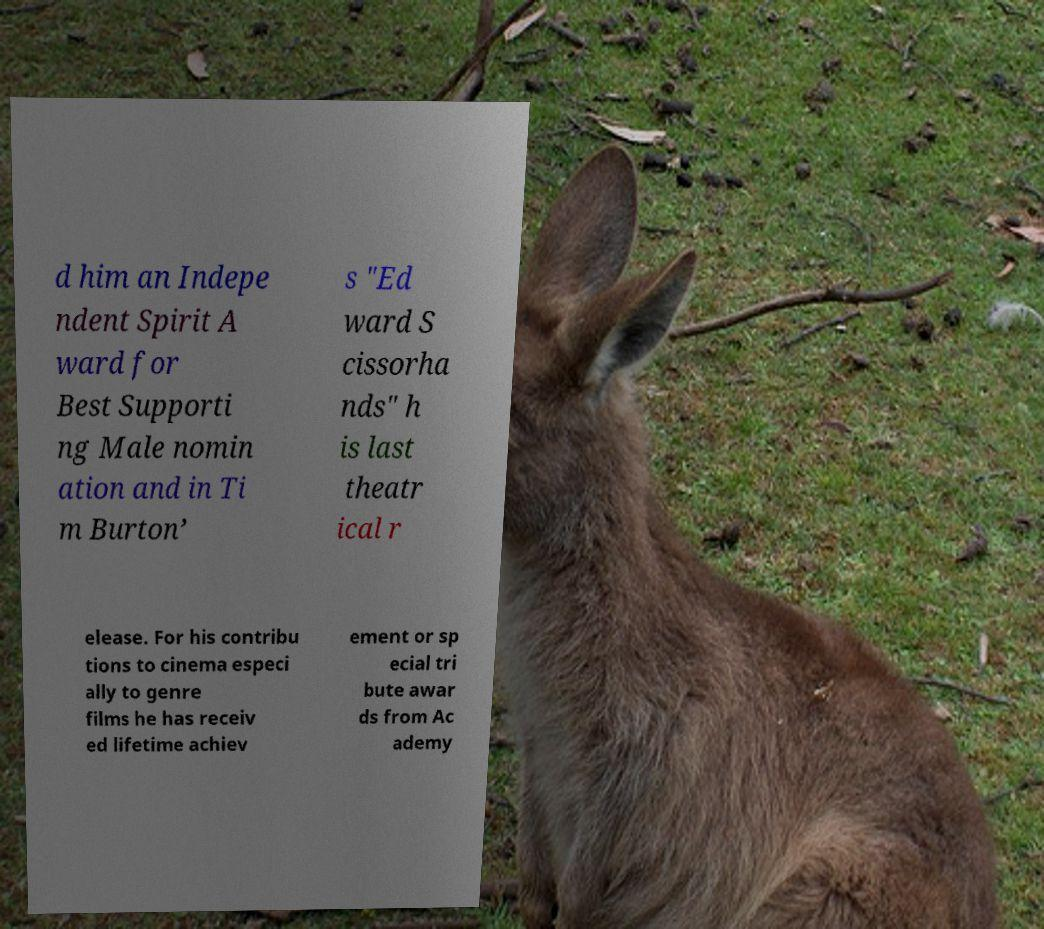Can you read and provide the text displayed in the image?This photo seems to have some interesting text. Can you extract and type it out for me? d him an Indepe ndent Spirit A ward for Best Supporti ng Male nomin ation and in Ti m Burton’ s "Ed ward S cissorha nds" h is last theatr ical r elease. For his contribu tions to cinema especi ally to genre films he has receiv ed lifetime achiev ement or sp ecial tri bute awar ds from Ac ademy 